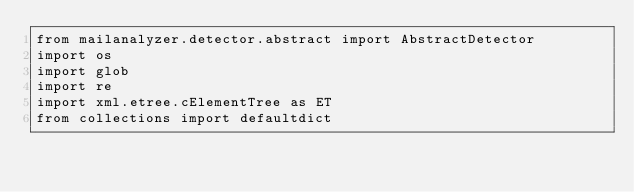<code> <loc_0><loc_0><loc_500><loc_500><_Python_>from mailanalyzer.detector.abstract import AbstractDetector
import os
import glob
import re
import xml.etree.cElementTree as ET
from collections import defaultdict
</code> 